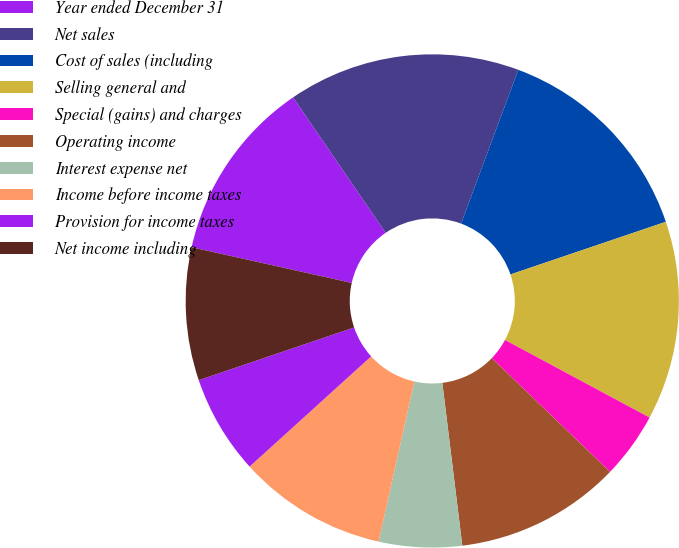<chart> <loc_0><loc_0><loc_500><loc_500><pie_chart><fcel>Year ended December 31<fcel>Net sales<fcel>Cost of sales (including<fcel>Selling general and<fcel>Special (gains) and charges<fcel>Operating income<fcel>Interest expense net<fcel>Income before income taxes<fcel>Provision for income taxes<fcel>Net income including<nl><fcel>11.96%<fcel>15.22%<fcel>14.13%<fcel>13.04%<fcel>4.35%<fcel>10.87%<fcel>5.44%<fcel>9.78%<fcel>6.52%<fcel>8.7%<nl></chart> 